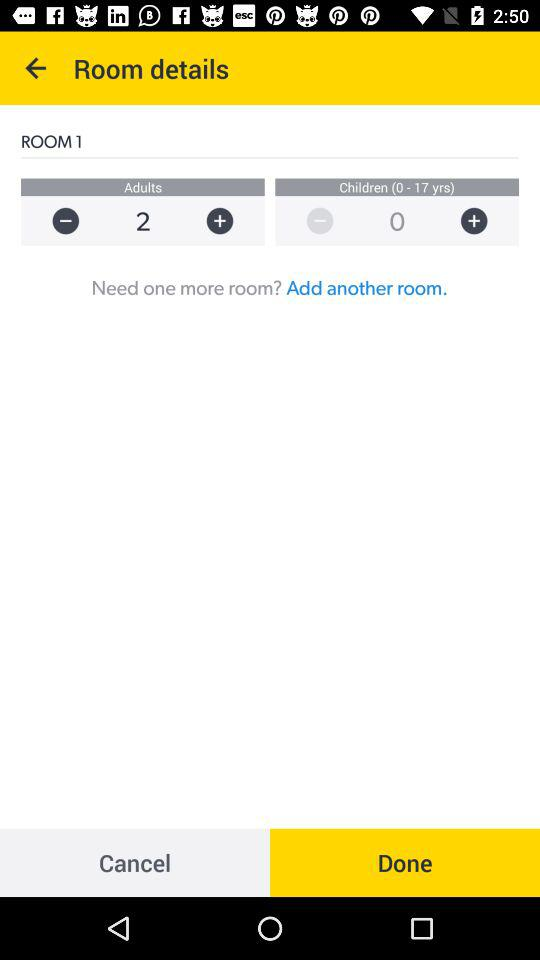What is the age group for children? The age group for children ranges from 0 to 17 years. 